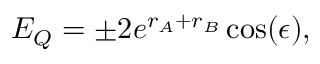<formula> <loc_0><loc_0><loc_500><loc_500>E _ { Q } = \pm 2 e ^ { r _ { A } + r _ { B } } \cos ( \epsilon ) ,</formula> 